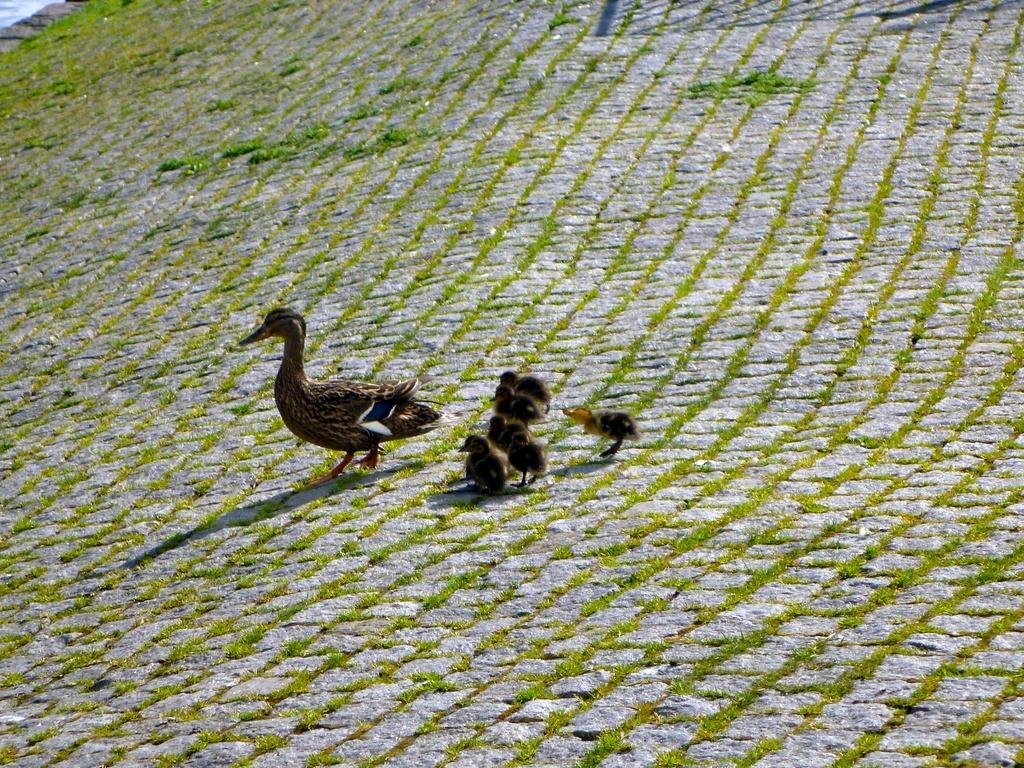What type of animals can be seen in the image? There are birds in the image. What color are the birds? The birds are brown in color. What can be seen in the background of the image? There is grass in the background of the image. What color is the grass? The grass is green in color. How many brothers are depicted with the birds in the image? There are no brothers present in the image; it features birds and grass. What type of shirt is the bird wearing in the image? Birds do not wear shirts, and there is no clothing visible in the image. 